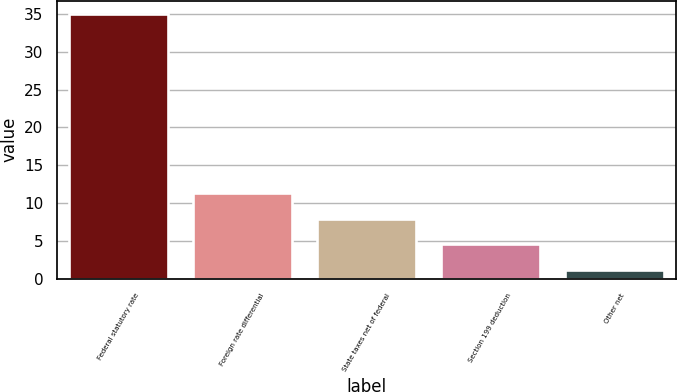Convert chart to OTSL. <chart><loc_0><loc_0><loc_500><loc_500><bar_chart><fcel>Federal statutory rate<fcel>Foreign rate differential<fcel>State taxes net of federal<fcel>Section 199 deduction<fcel>Other net<nl><fcel>35<fcel>11.34<fcel>7.96<fcel>4.58<fcel>1.2<nl></chart> 